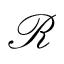<formula> <loc_0><loc_0><loc_500><loc_500>\mathcal { R }</formula> 